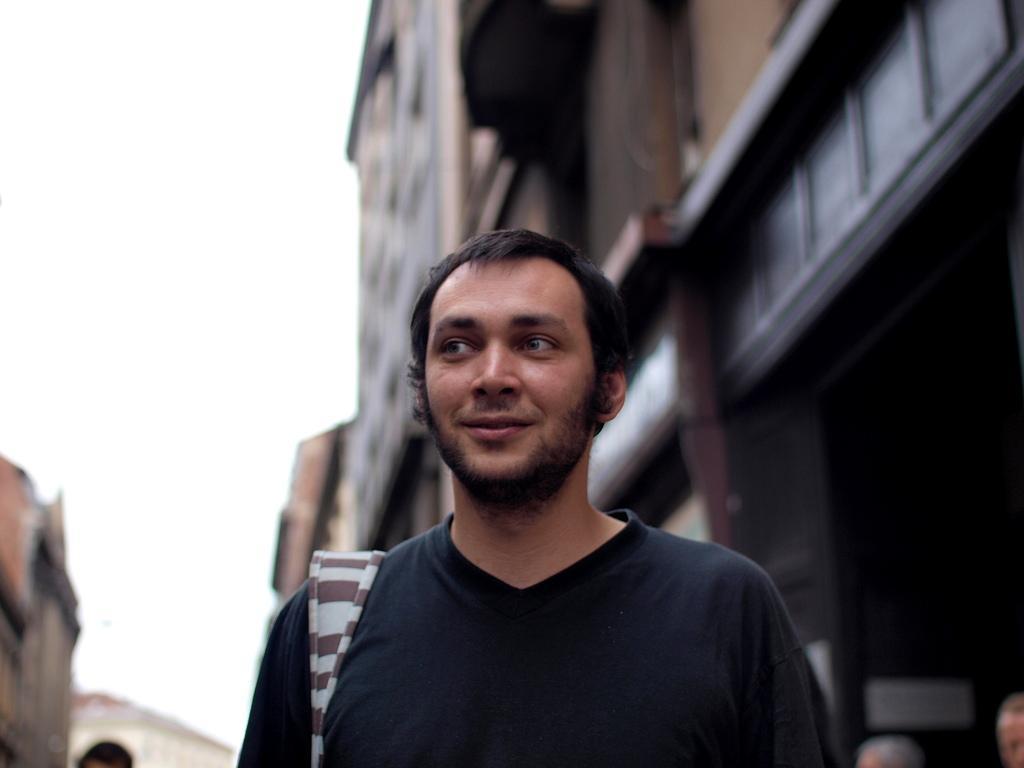How would you summarize this image in a sentence or two? In this image I can see a man in the front and I can see he is wearing black colour t shirt. In the background I can see few buildings and on the bottom side of this image I can see few heads of people. I can also see this image is little bit blurry in the background. 